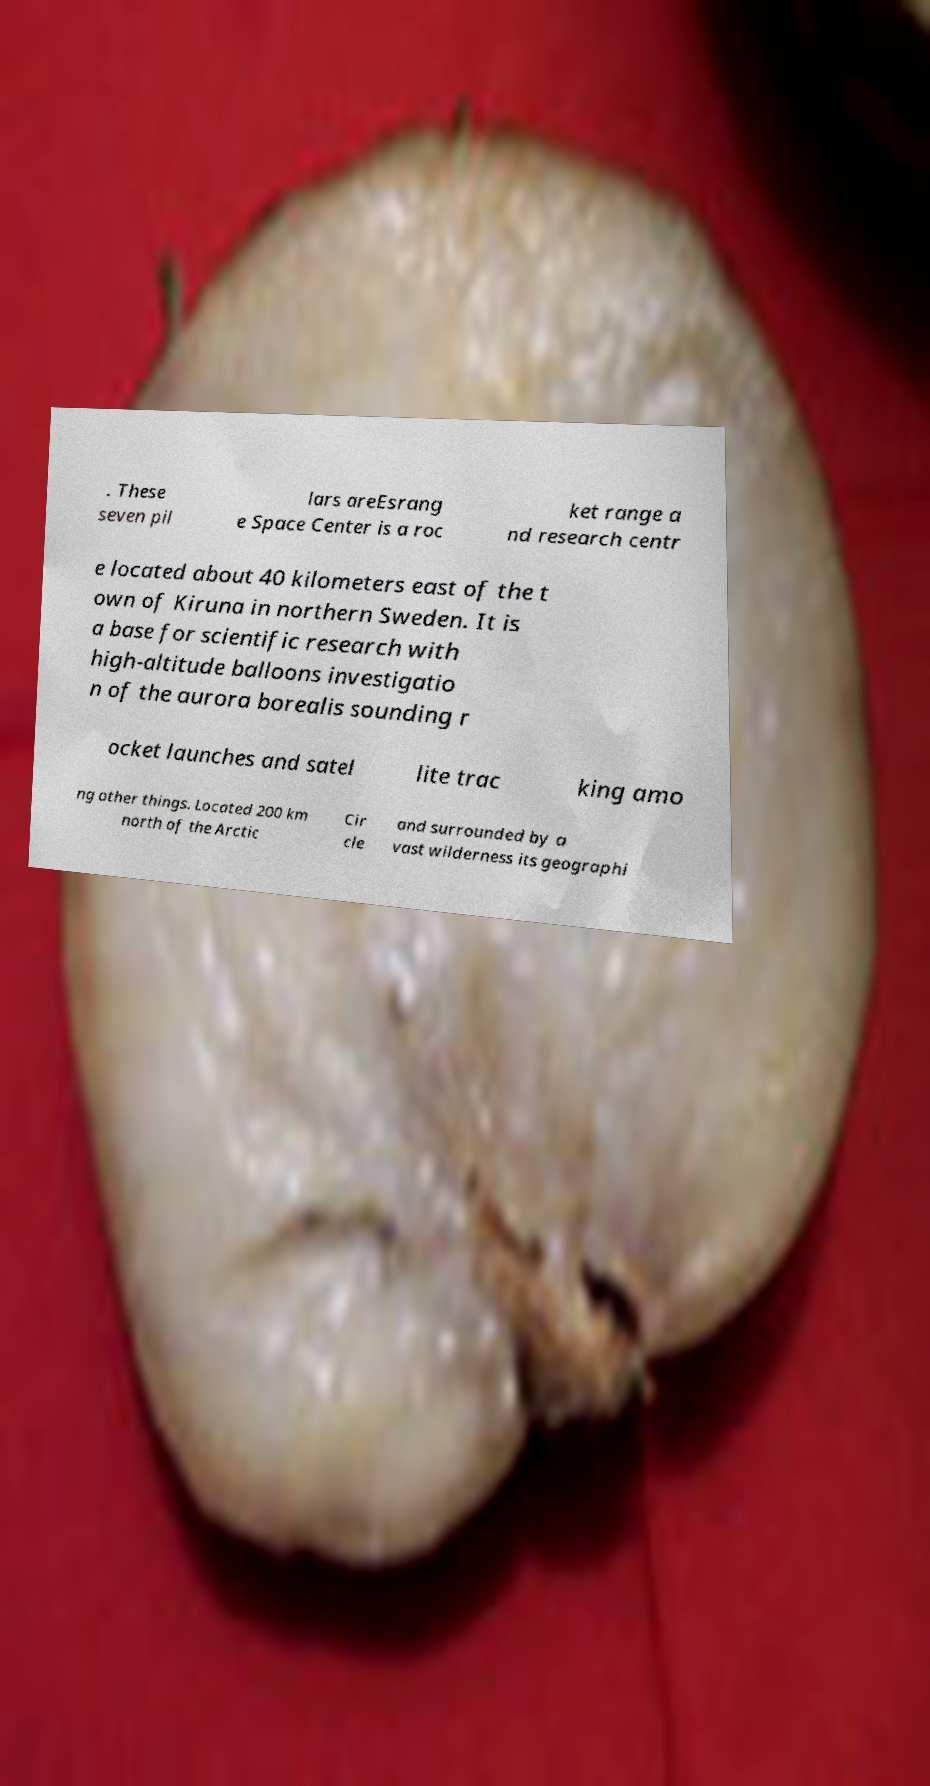Please read and relay the text visible in this image. What does it say? . These seven pil lars areEsrang e Space Center is a roc ket range a nd research centr e located about 40 kilometers east of the t own of Kiruna in northern Sweden. It is a base for scientific research with high-altitude balloons investigatio n of the aurora borealis sounding r ocket launches and satel lite trac king amo ng other things. Located 200 km north of the Arctic Cir cle and surrounded by a vast wilderness its geographi 